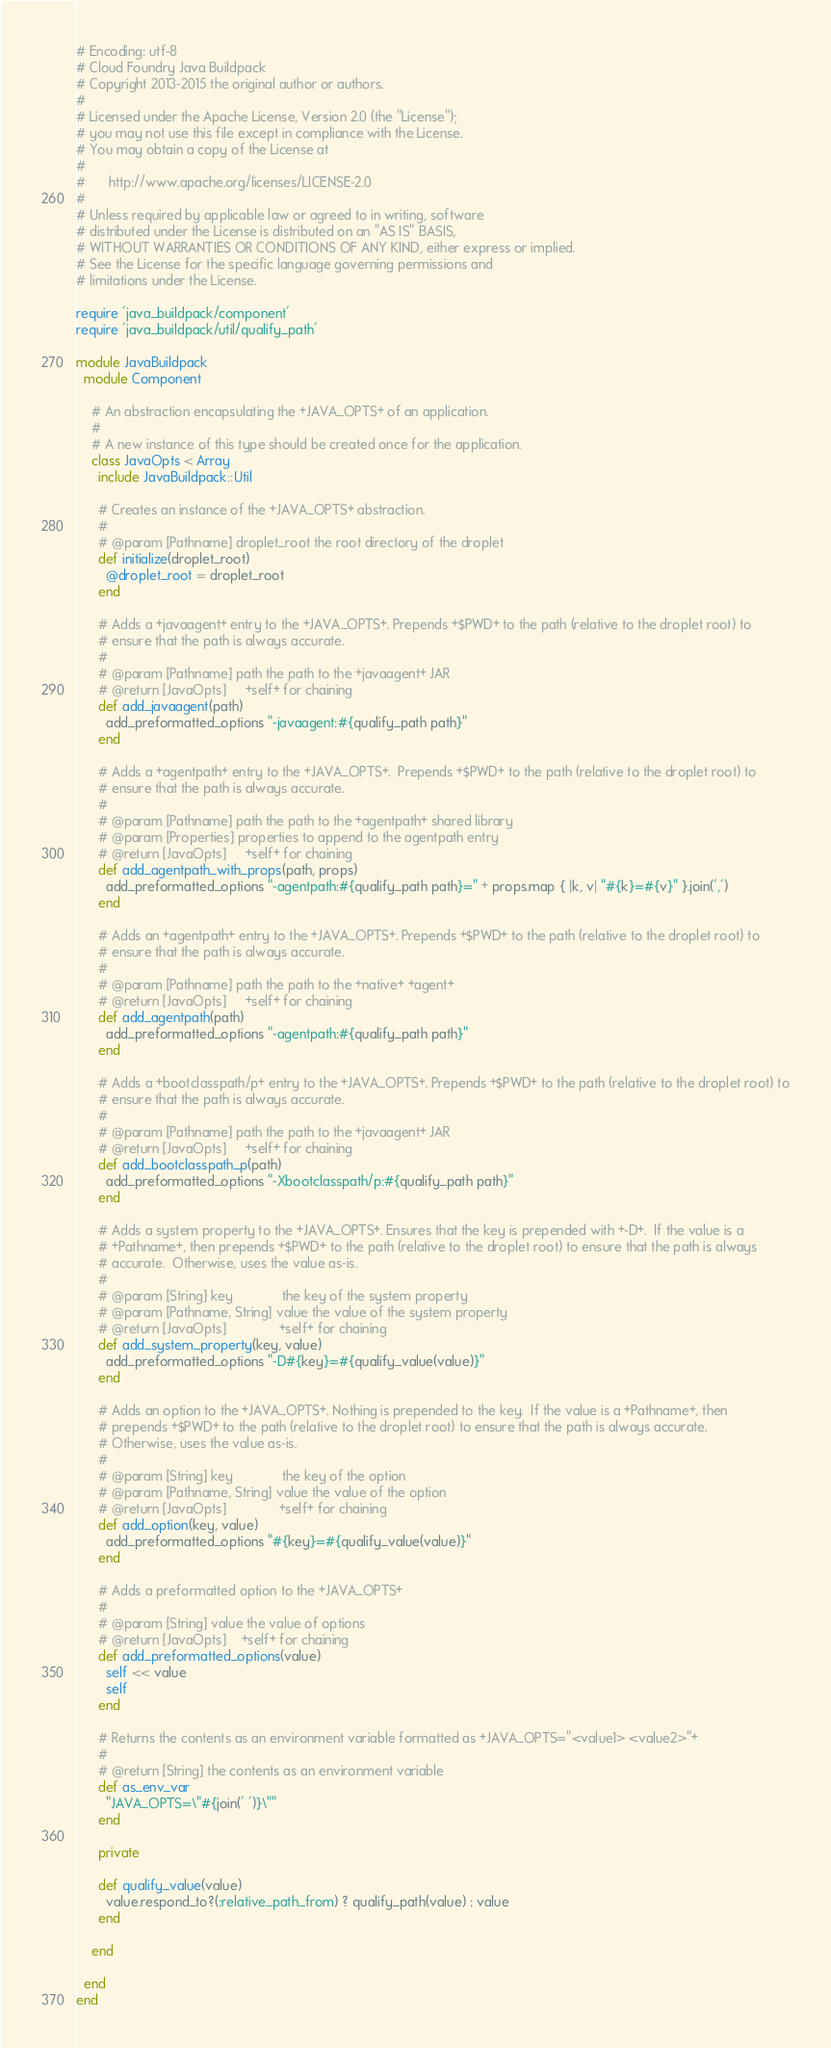Convert code to text. <code><loc_0><loc_0><loc_500><loc_500><_Ruby_># Encoding: utf-8
# Cloud Foundry Java Buildpack
# Copyright 2013-2015 the original author or authors.
#
# Licensed under the Apache License, Version 2.0 (the "License");
# you may not use this file except in compliance with the License.
# You may obtain a copy of the License at
#
#      http://www.apache.org/licenses/LICENSE-2.0
#
# Unless required by applicable law or agreed to in writing, software
# distributed under the License is distributed on an "AS IS" BASIS,
# WITHOUT WARRANTIES OR CONDITIONS OF ANY KIND, either express or implied.
# See the License for the specific language governing permissions and
# limitations under the License.

require 'java_buildpack/component'
require 'java_buildpack/util/qualify_path'

module JavaBuildpack
  module Component

    # An abstraction encapsulating the +JAVA_OPTS+ of an application.
    #
    # A new instance of this type should be created once for the application.
    class JavaOpts < Array
      include JavaBuildpack::Util

      # Creates an instance of the +JAVA_OPTS+ abstraction.
      #
      # @param [Pathname] droplet_root the root directory of the droplet
      def initialize(droplet_root)
        @droplet_root = droplet_root
      end

      # Adds a +javaagent+ entry to the +JAVA_OPTS+. Prepends +$PWD+ to the path (relative to the droplet root) to
      # ensure that the path is always accurate.
      #
      # @param [Pathname] path the path to the +javaagent+ JAR
      # @return [JavaOpts]     +self+ for chaining
      def add_javaagent(path)
        add_preformatted_options "-javaagent:#{qualify_path path}"
      end

      # Adds a +agentpath+ entry to the +JAVA_OPTS+.  Prepends +$PWD+ to the path (relative to the droplet root) to
      # ensure that the path is always accurate.
      #
      # @param [Pathname] path the path to the +agentpath+ shared library
      # @param [Properties] properties to append to the agentpath entry
      # @return [JavaOpts]     +self+ for chaining
      def add_agentpath_with_props(path, props)
        add_preformatted_options "-agentpath:#{qualify_path path}=" + props.map { |k, v| "#{k}=#{v}" }.join(',')
      end

      # Adds an +agentpath+ entry to the +JAVA_OPTS+. Prepends +$PWD+ to the path (relative to the droplet root) to
      # ensure that the path is always accurate.
      #
      # @param [Pathname] path the path to the +native+ +agent+
      # @return [JavaOpts]     +self+ for chaining
      def add_agentpath(path)
        add_preformatted_options "-agentpath:#{qualify_path path}"
      end

      # Adds a +bootclasspath/p+ entry to the +JAVA_OPTS+. Prepends +$PWD+ to the path (relative to the droplet root) to
      # ensure that the path is always accurate.
      #
      # @param [Pathname] path the path to the +javaagent+ JAR
      # @return [JavaOpts]     +self+ for chaining
      def add_bootclasspath_p(path)
        add_preformatted_options "-Xbootclasspath/p:#{qualify_path path}"
      end

      # Adds a system property to the +JAVA_OPTS+. Ensures that the key is prepended with +-D+.  If the value is a
      # +Pathname+, then prepends +$PWD+ to the path (relative to the droplet root) to ensure that the path is always
      # accurate.  Otherwise, uses the value as-is.
      #
      # @param [String] key             the key of the system property
      # @param [Pathname, String] value the value of the system property
      # @return [JavaOpts]              +self+ for chaining
      def add_system_property(key, value)
        add_preformatted_options "-D#{key}=#{qualify_value(value)}"
      end

      # Adds an option to the +JAVA_OPTS+. Nothing is prepended to the key.  If the value is a +Pathname+, then
      # prepends +$PWD+ to the path (relative to the droplet root) to ensure that the path is always accurate.
      # Otherwise, uses the value as-is.
      #
      # @param [String] key             the key of the option
      # @param [Pathname, String] value the value of the option
      # @return [JavaOpts]              +self+ for chaining
      def add_option(key, value)
        add_preformatted_options "#{key}=#{qualify_value(value)}"
      end

      # Adds a preformatted option to the +JAVA_OPTS+
      #
      # @param [String] value the value of options
      # @return [JavaOpts]    +self+ for chaining
      def add_preformatted_options(value)
        self << value
        self
      end

      # Returns the contents as an environment variable formatted as +JAVA_OPTS="<value1> <value2>"+
      #
      # @return [String] the contents as an environment variable
      def as_env_var
        "JAVA_OPTS=\"#{join(' ')}\""
      end

      private

      def qualify_value(value)
        value.respond_to?(:relative_path_from) ? qualify_path(value) : value
      end

    end

  end
end
</code> 